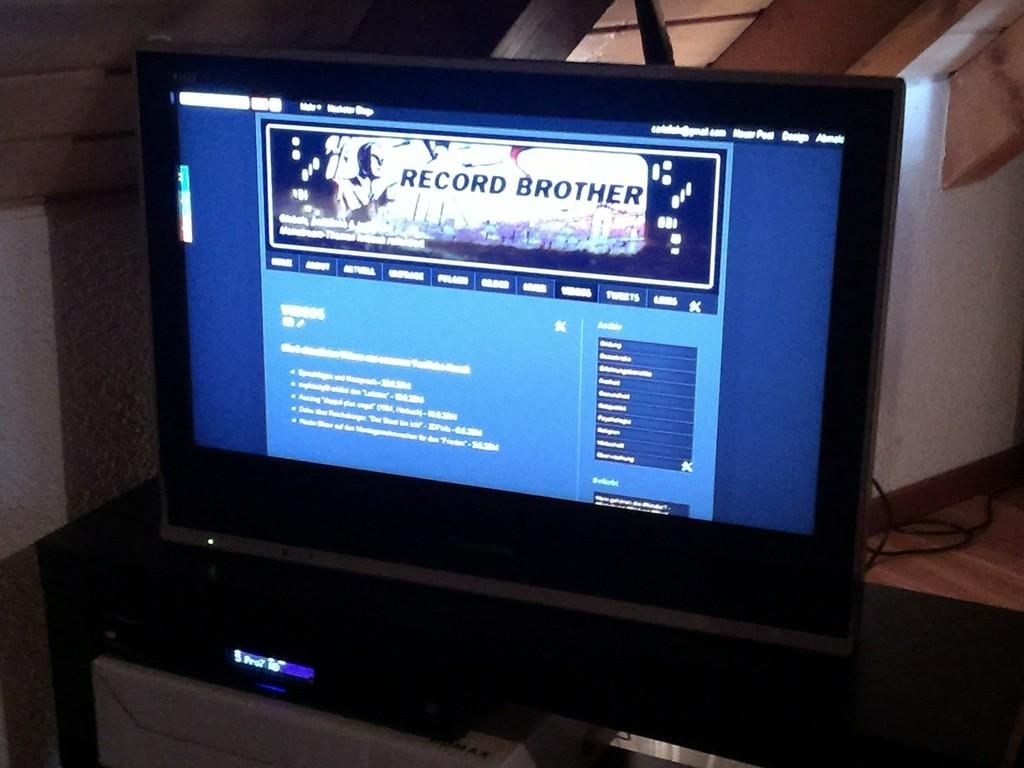Provide a one-sentence caption for the provided image. The new post button is located on the top right. 